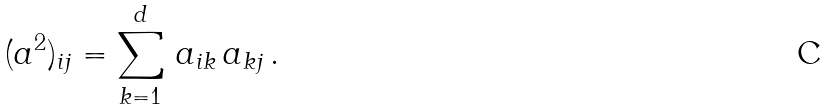Convert formula to latex. <formula><loc_0><loc_0><loc_500><loc_500>( { a } ^ { 2 } ) _ { i j } = \sum _ { k = 1 } ^ { d } \, a _ { i k } \, a _ { k j } \, .</formula> 